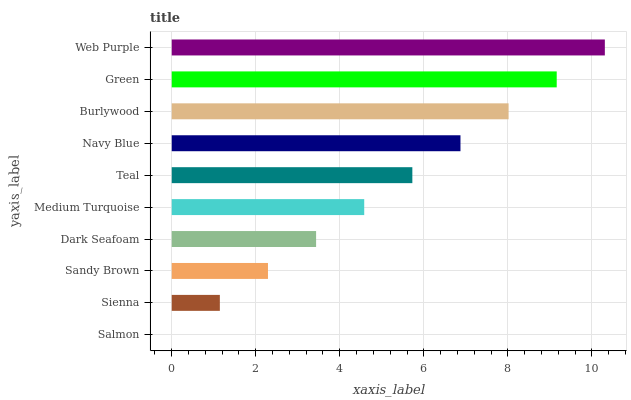Is Salmon the minimum?
Answer yes or no. Yes. Is Web Purple the maximum?
Answer yes or no. Yes. Is Sienna the minimum?
Answer yes or no. No. Is Sienna the maximum?
Answer yes or no. No. Is Sienna greater than Salmon?
Answer yes or no. Yes. Is Salmon less than Sienna?
Answer yes or no. Yes. Is Salmon greater than Sienna?
Answer yes or no. No. Is Sienna less than Salmon?
Answer yes or no. No. Is Teal the high median?
Answer yes or no. Yes. Is Medium Turquoise the low median?
Answer yes or no. Yes. Is Green the high median?
Answer yes or no. No. Is Teal the low median?
Answer yes or no. No. 